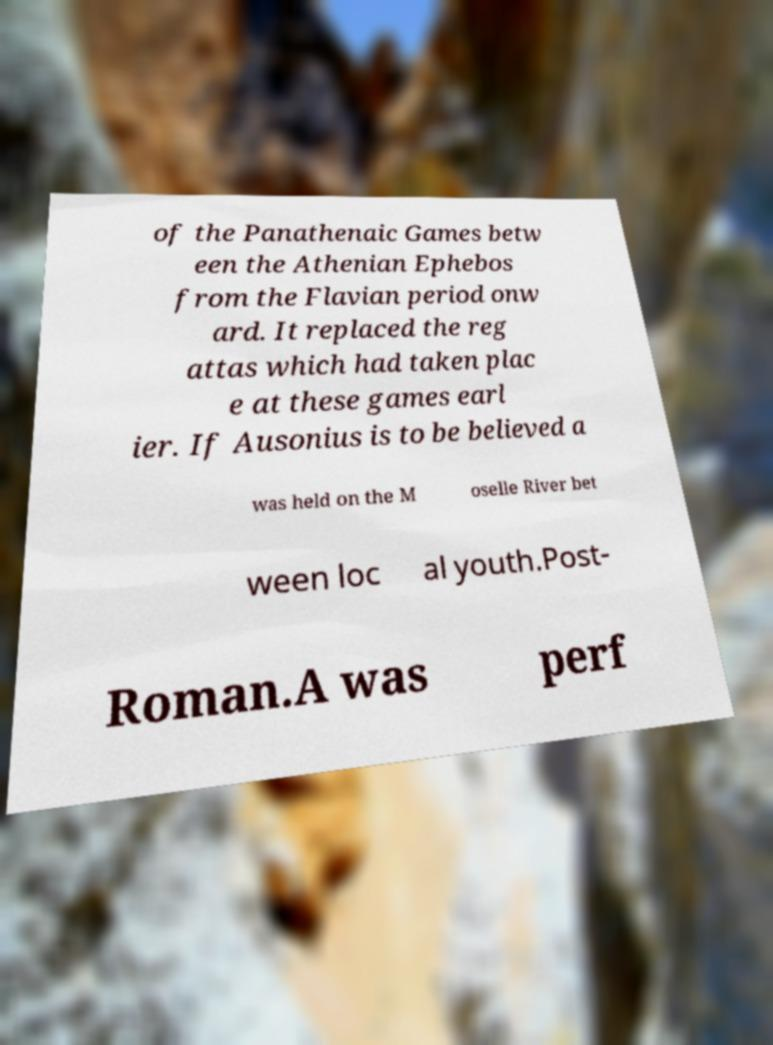Could you assist in decoding the text presented in this image and type it out clearly? of the Panathenaic Games betw een the Athenian Ephebos from the Flavian period onw ard. It replaced the reg attas which had taken plac e at these games earl ier. If Ausonius is to be believed a was held on the M oselle River bet ween loc al youth.Post- Roman.A was perf 